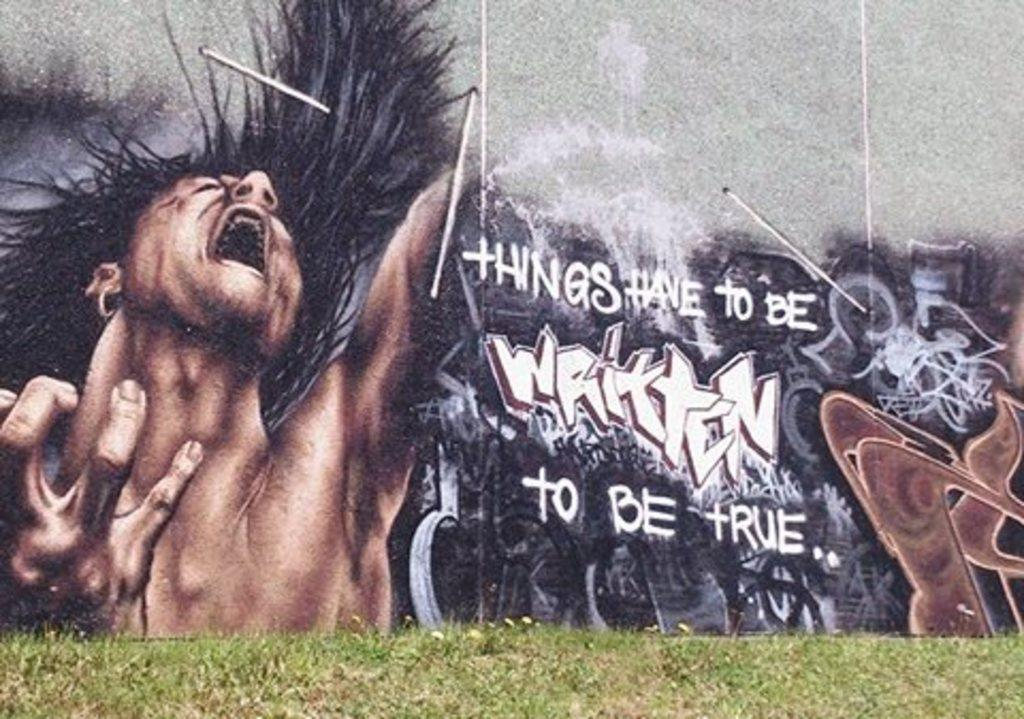<image>
Provide a brief description of the given image. A wall that has things have to be written to be true in white letters 